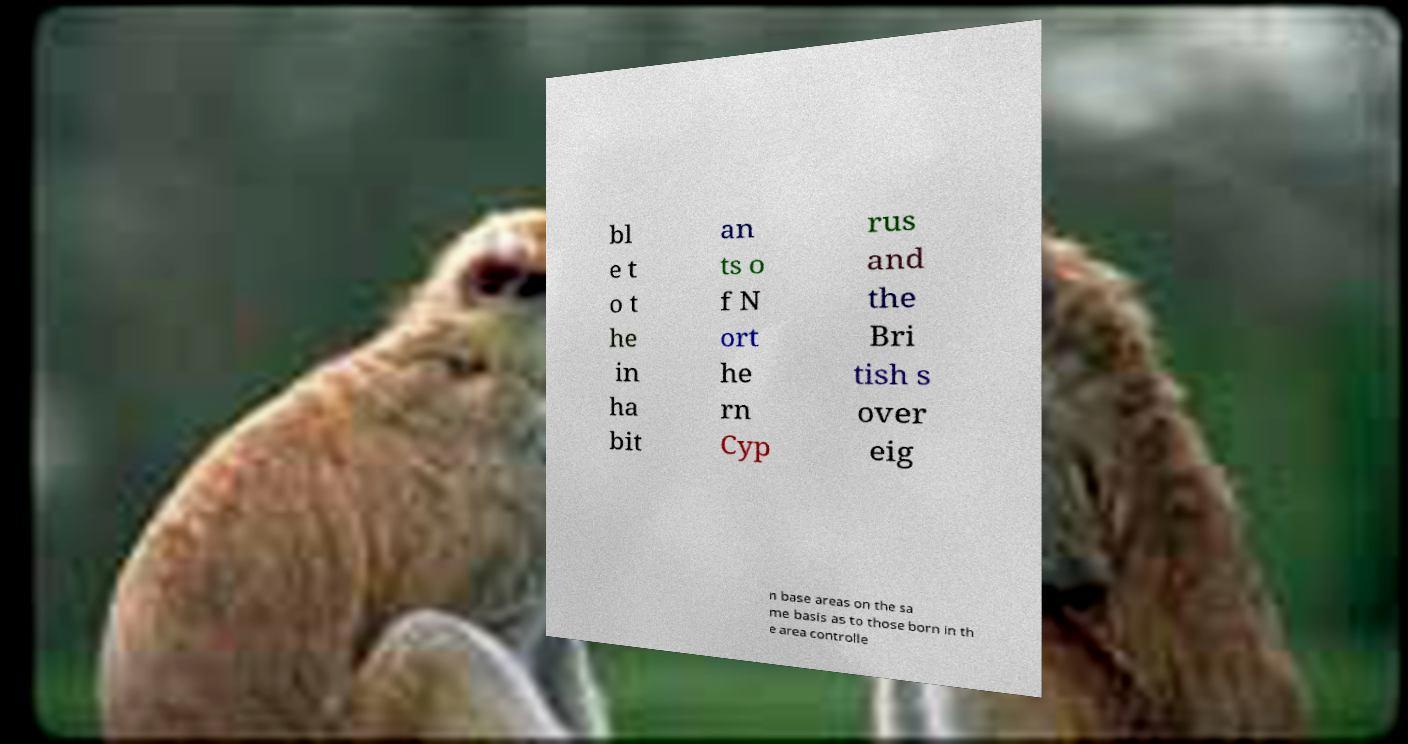Can you accurately transcribe the text from the provided image for me? bl e t o t he in ha bit an ts o f N ort he rn Cyp rus and the Bri tish s over eig n base areas on the sa me basis as to those born in th e area controlle 